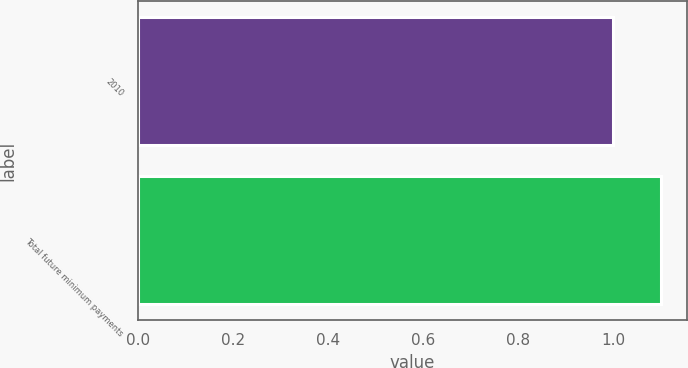Convert chart. <chart><loc_0><loc_0><loc_500><loc_500><bar_chart><fcel>2010<fcel>Total future minimum payments<nl><fcel>1<fcel>1.1<nl></chart> 